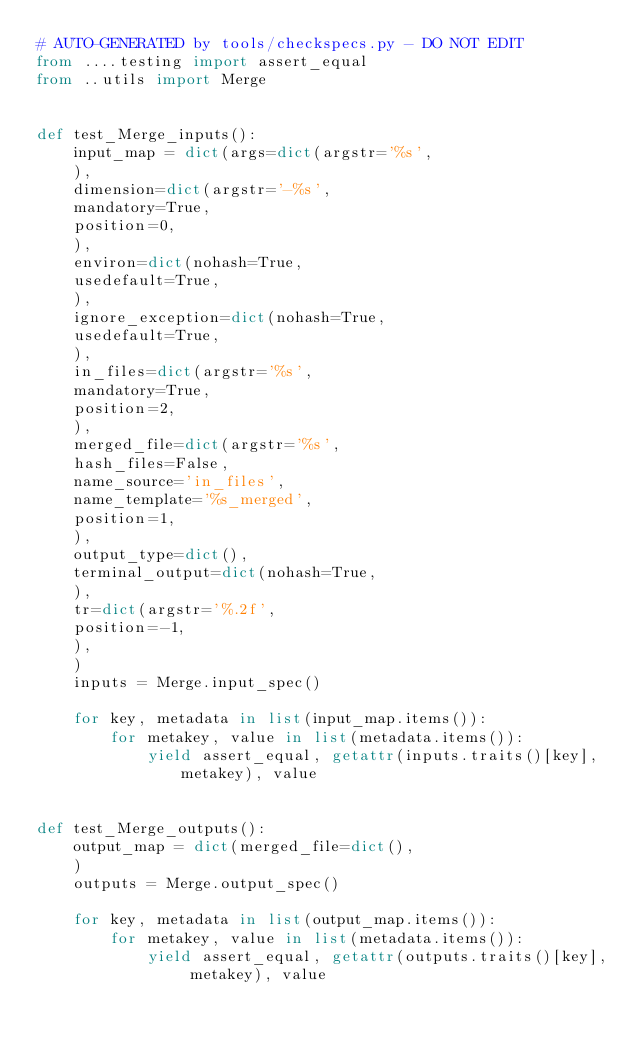<code> <loc_0><loc_0><loc_500><loc_500><_Python_># AUTO-GENERATED by tools/checkspecs.py - DO NOT EDIT
from ....testing import assert_equal
from ..utils import Merge


def test_Merge_inputs():
    input_map = dict(args=dict(argstr='%s',
    ),
    dimension=dict(argstr='-%s',
    mandatory=True,
    position=0,
    ),
    environ=dict(nohash=True,
    usedefault=True,
    ),
    ignore_exception=dict(nohash=True,
    usedefault=True,
    ),
    in_files=dict(argstr='%s',
    mandatory=True,
    position=2,
    ),
    merged_file=dict(argstr='%s',
    hash_files=False,
    name_source='in_files',
    name_template='%s_merged',
    position=1,
    ),
    output_type=dict(),
    terminal_output=dict(nohash=True,
    ),
    tr=dict(argstr='%.2f',
    position=-1,
    ),
    )
    inputs = Merge.input_spec()

    for key, metadata in list(input_map.items()):
        for metakey, value in list(metadata.items()):
            yield assert_equal, getattr(inputs.traits()[key], metakey), value


def test_Merge_outputs():
    output_map = dict(merged_file=dict(),
    )
    outputs = Merge.output_spec()

    for key, metadata in list(output_map.items()):
        for metakey, value in list(metadata.items()):
            yield assert_equal, getattr(outputs.traits()[key], metakey), value
</code> 